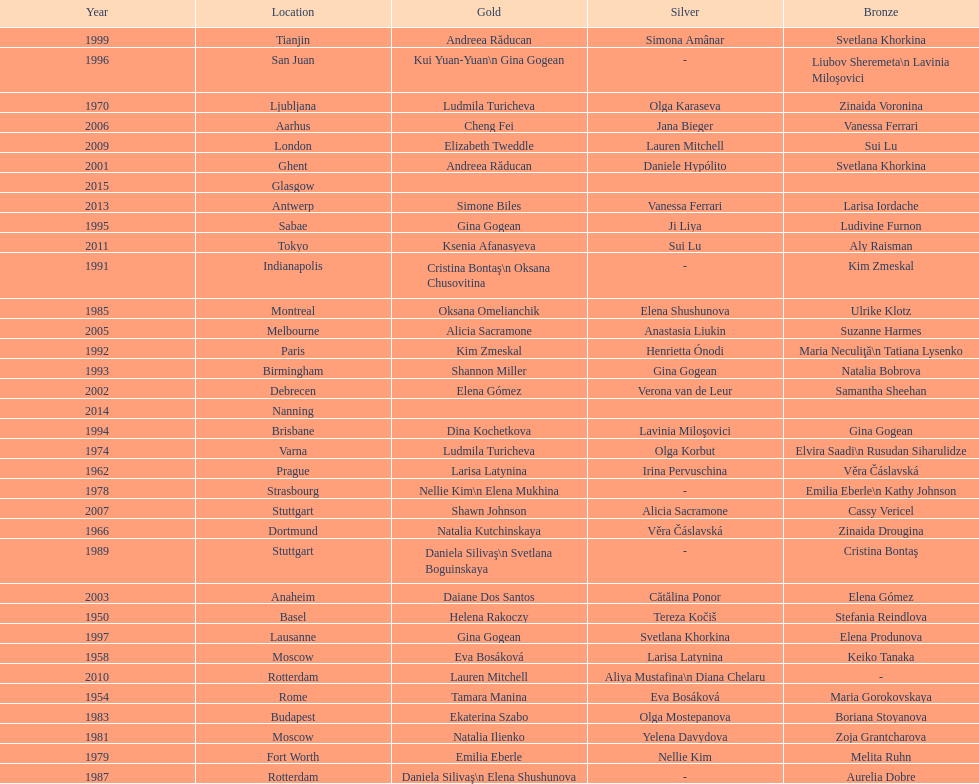What is the total number of russian gymnasts that have won silver. 8. 